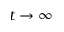<formula> <loc_0><loc_0><loc_500><loc_500>t \to \infty</formula> 